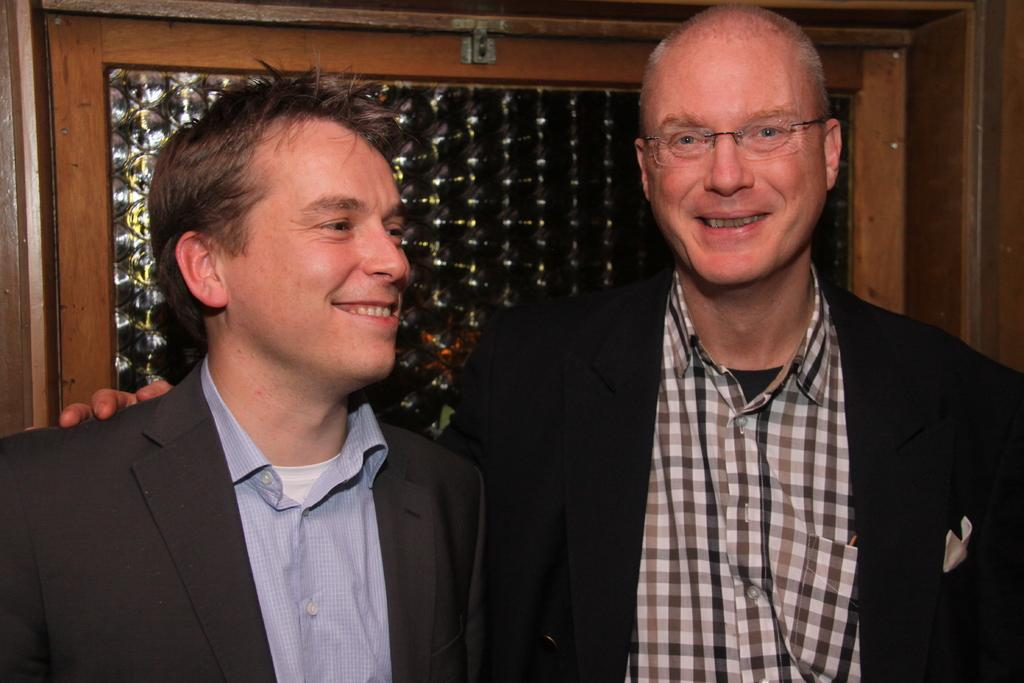How many people are present in the image? There are two persons in the image. What can be observed about the attire of the persons in the image? Both persons are wearing clothes. What type of society can be seen living around the lake in the image? There is no lake or society present in the image; it only features two persons wearing clothes. How many clouds are visible in the image? There are no clouds visible in the image; it only features two persons wearing clothes. 